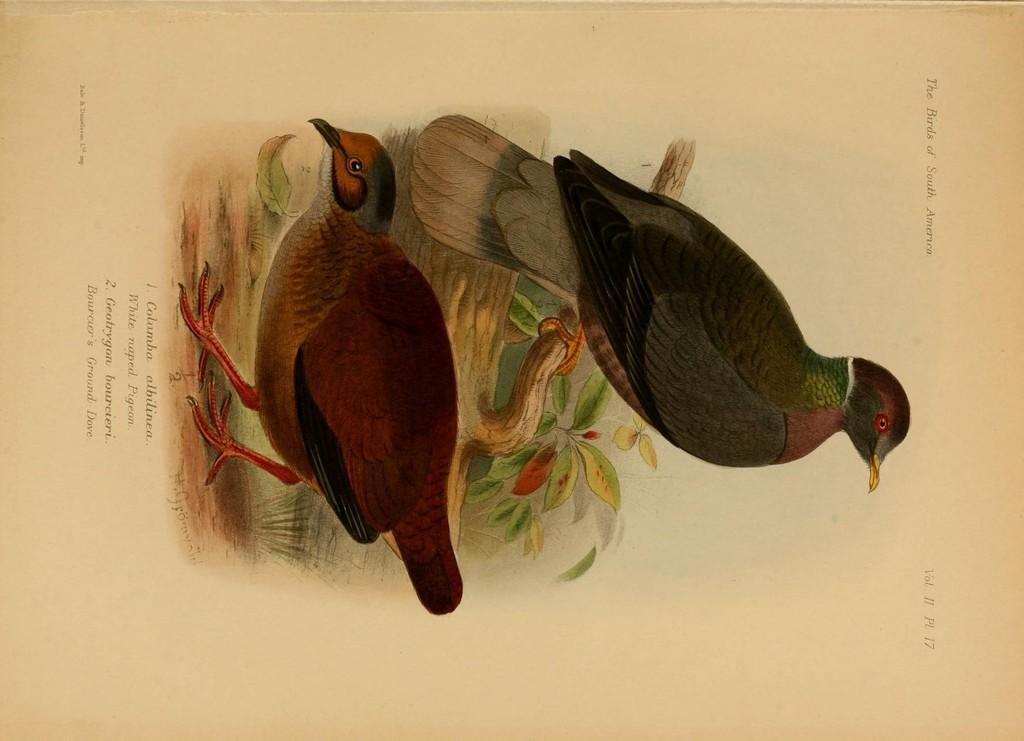Can you describe this image briefly? This image consists of a paper with an art of two birds and there is a text on it. 